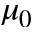<formula> <loc_0><loc_0><loc_500><loc_500>\mu _ { 0 }</formula> 